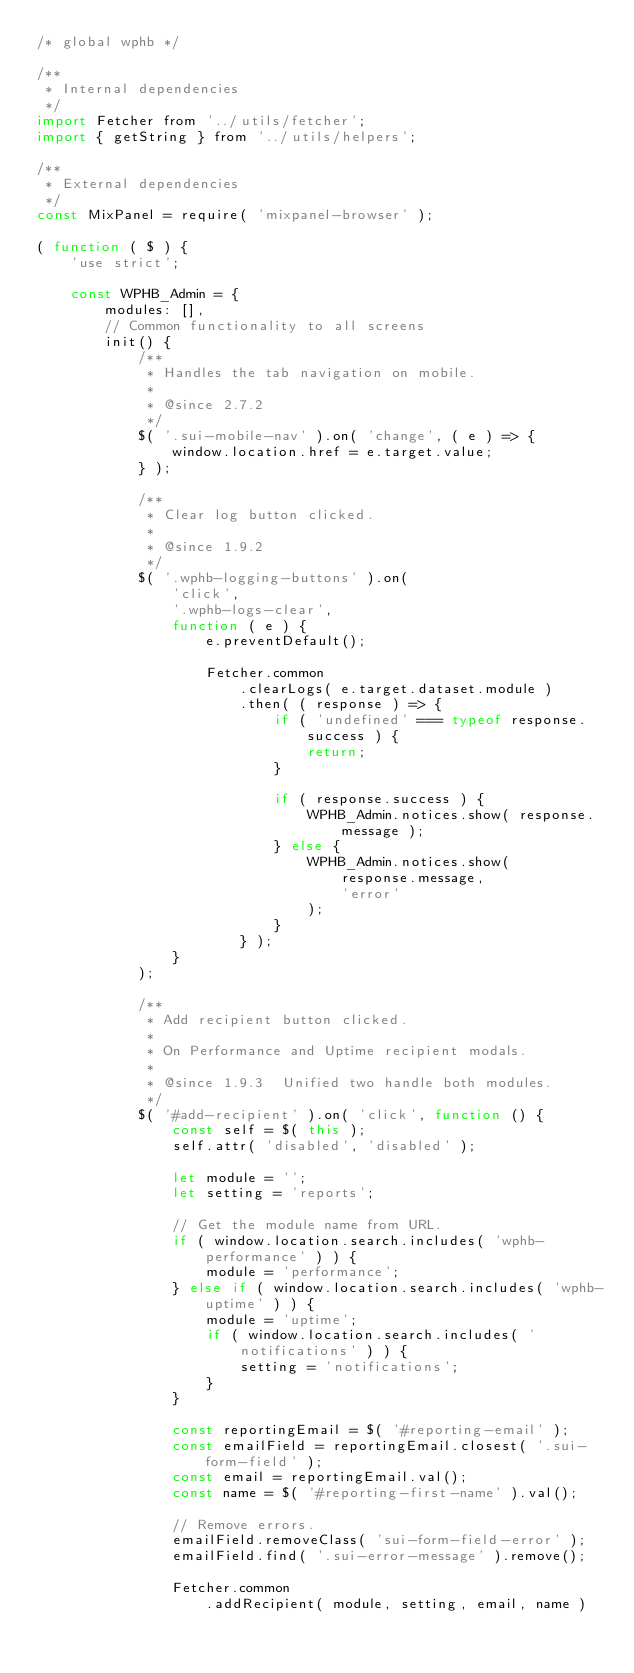<code> <loc_0><loc_0><loc_500><loc_500><_JavaScript_>/* global wphb */

/**
 * Internal dependencies
 */
import Fetcher from '../utils/fetcher';
import { getString } from '../utils/helpers';

/**
 * External dependencies
 */
const MixPanel = require( 'mixpanel-browser' );

( function ( $ ) {
	'use strict';

	const WPHB_Admin = {
		modules: [],
		// Common functionality to all screens
		init() {
			/**
			 * Handles the tab navigation on mobile.
			 *
			 * @since 2.7.2
			 */
			$( '.sui-mobile-nav' ).on( 'change', ( e ) => {
				window.location.href = e.target.value;
			} );

			/**
			 * Clear log button clicked.
			 *
			 * @since 1.9.2
			 */
			$( '.wphb-logging-buttons' ).on(
				'click',
				'.wphb-logs-clear',
				function ( e ) {
					e.preventDefault();

					Fetcher.common
						.clearLogs( e.target.dataset.module )
						.then( ( response ) => {
							if ( 'undefined' === typeof response.success ) {
								return;
							}

							if ( response.success ) {
								WPHB_Admin.notices.show( response.message );
							} else {
								WPHB_Admin.notices.show(
									response.message,
									'error'
								);
							}
						} );
				}
			);

			/**
			 * Add recipient button clicked.
			 *
			 * On Performance and Uptime recipient modals.
			 *
			 * @since 1.9.3  Unified two handle both modules.
			 */
			$( '#add-recipient' ).on( 'click', function () {
				const self = $( this );
				self.attr( 'disabled', 'disabled' );

				let module = '';
				let setting = 'reports';

				// Get the module name from URL.
				if ( window.location.search.includes( 'wphb-performance' ) ) {
					module = 'performance';
				} else if ( window.location.search.includes( 'wphb-uptime' ) ) {
					module = 'uptime';
					if ( window.location.search.includes( 'notifications' ) ) {
						setting = 'notifications';
					}
				}

				const reportingEmail = $( '#reporting-email' );
				const emailField = reportingEmail.closest( '.sui-form-field' );
				const email = reportingEmail.val();
				const name = $( '#reporting-first-name' ).val();

				// Remove errors.
				emailField.removeClass( 'sui-form-field-error' );
				emailField.find( '.sui-error-message' ).remove();

				Fetcher.common
					.addRecipient( module, setting, email, name )</code> 